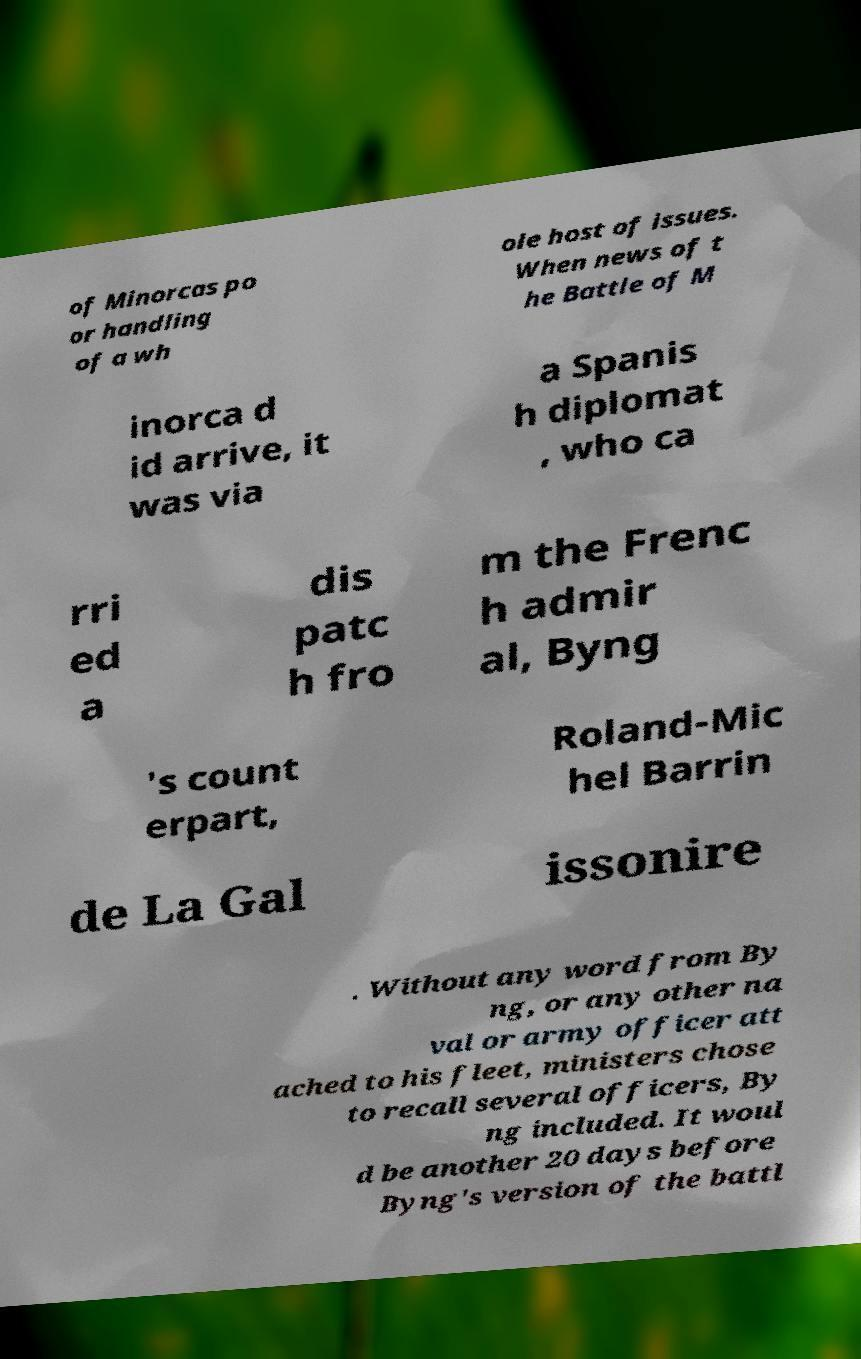Can you accurately transcribe the text from the provided image for me? of Minorcas po or handling of a wh ole host of issues. When news of t he Battle of M inorca d id arrive, it was via a Spanis h diplomat , who ca rri ed a dis patc h fro m the Frenc h admir al, Byng 's count erpart, Roland-Mic hel Barrin de La Gal issonire . Without any word from By ng, or any other na val or army officer att ached to his fleet, ministers chose to recall several officers, By ng included. It woul d be another 20 days before Byng's version of the battl 